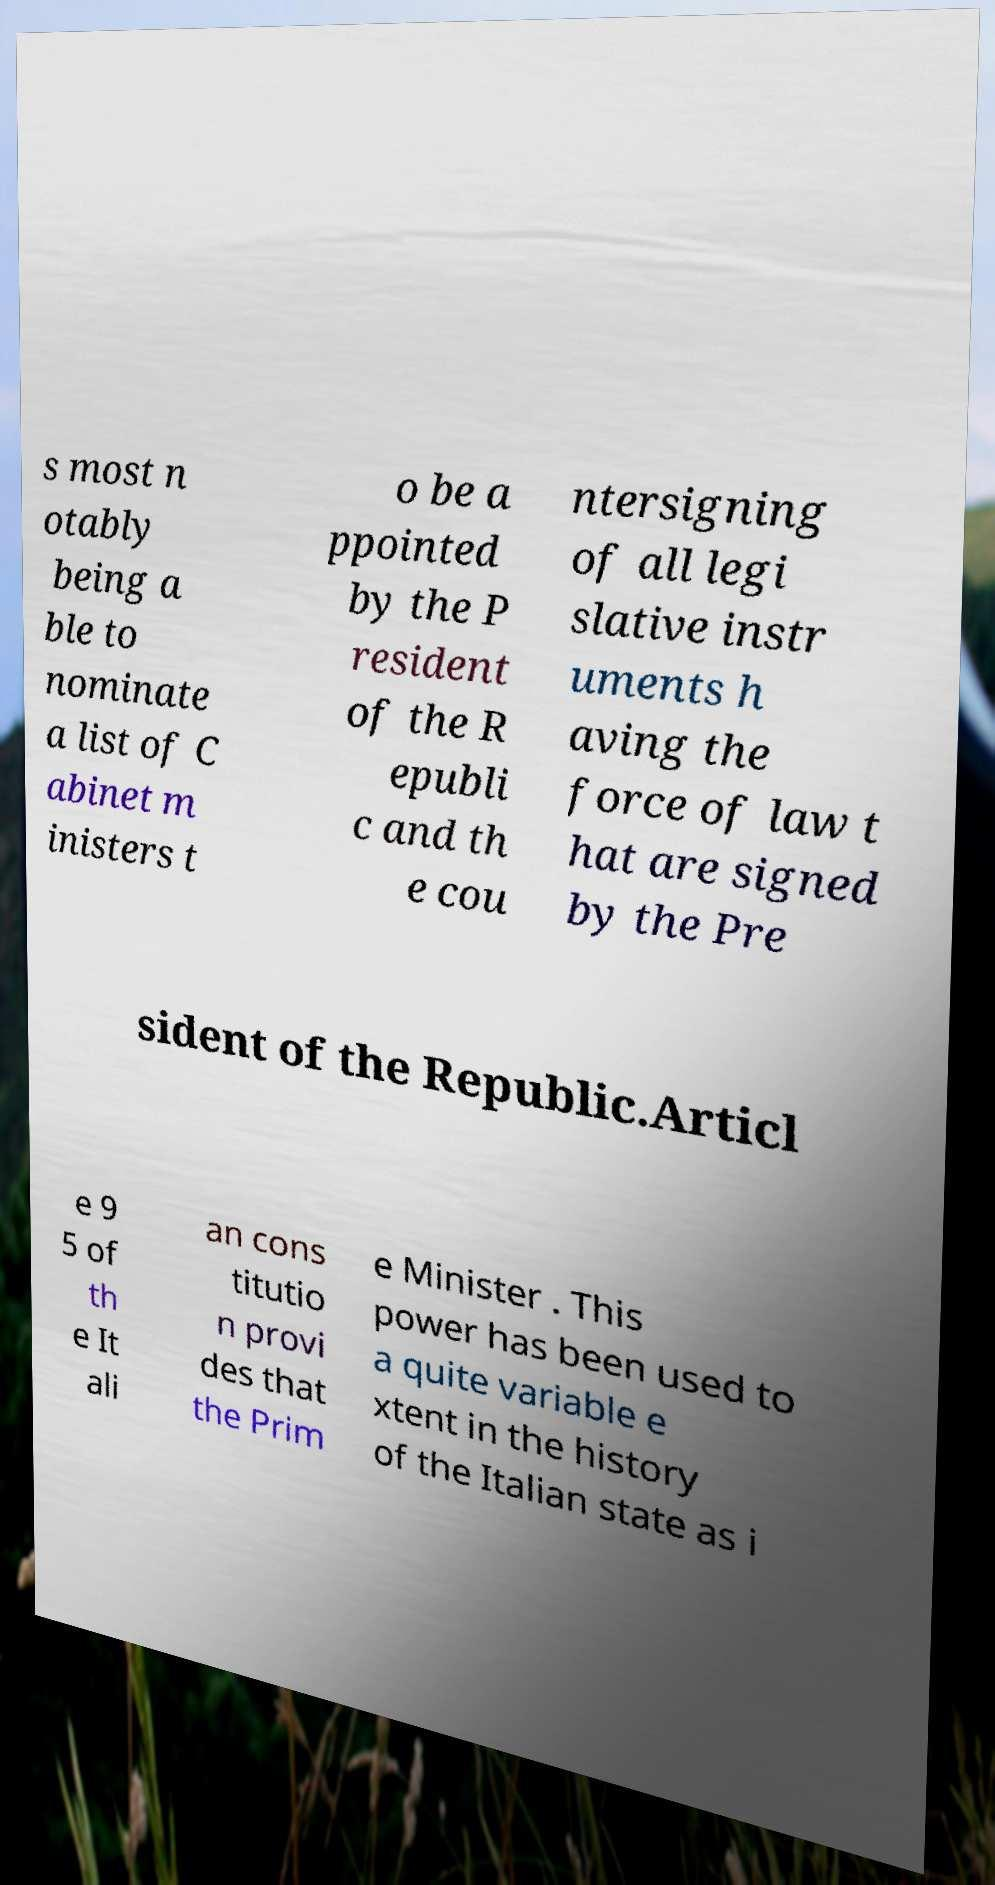I need the written content from this picture converted into text. Can you do that? s most n otably being a ble to nominate a list of C abinet m inisters t o be a ppointed by the P resident of the R epubli c and th e cou ntersigning of all legi slative instr uments h aving the force of law t hat are signed by the Pre sident of the Republic.Articl e 9 5 of th e It ali an cons titutio n provi des that the Prim e Minister . This power has been used to a quite variable e xtent in the history of the Italian state as i 